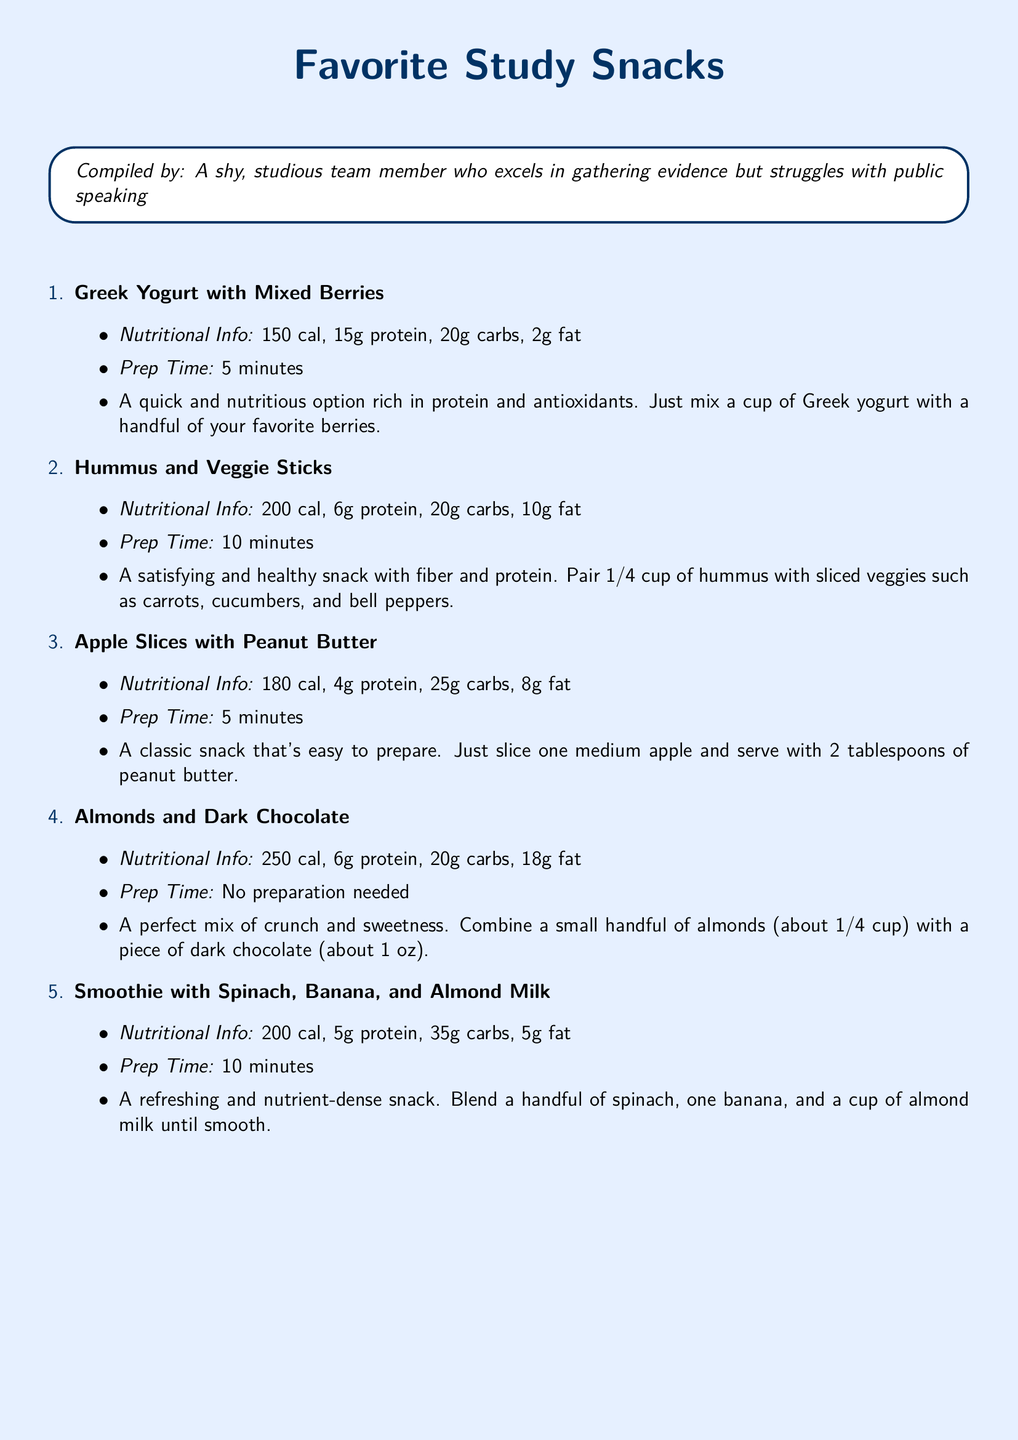What is the prep time for Greek Yogurt with Mixed Berries? The prep time for Greek Yogurt with Mixed Berries is specifically stated in the document.
Answer: 5 minutes How many calories are in the Smoothie with Spinach, Banana, and Almond Milk? The document lists the nutritional information, including calories, for each snack.
Answer: 200 cal What is the protein content in Hummus and Veggie Sticks? The protein content is part of the nutritional information provided for Hummus and Veggie Sticks in the document.
Answer: 6g protein Which snack has the highest fat content? To find the snack with the highest fat content, we compare the fat amounts listed for each snack in the document.
Answer: Almonds and Dark Chocolate What two main ingredients are in the smoothie? The document specifies the ingredients used in the smoothie, which are detailed in its description.
Answer: Spinach, Banana How long does it take to prepare Apple Slices with Peanut Butter? The document provides the prep time for each snack, including Apple Slices with Peanut Butter.
Answer: 5 minutes What snack involves no preparation? The document indicates which snack requires no preparation by stating "No preparation needed."
Answer: Almonds and Dark Chocolate What is the total carb content in Hummus and Veggie Sticks? The total carbs for Hummus and Veggie Sticks is part of the nutritional information given in the document.
Answer: 20g carbs 